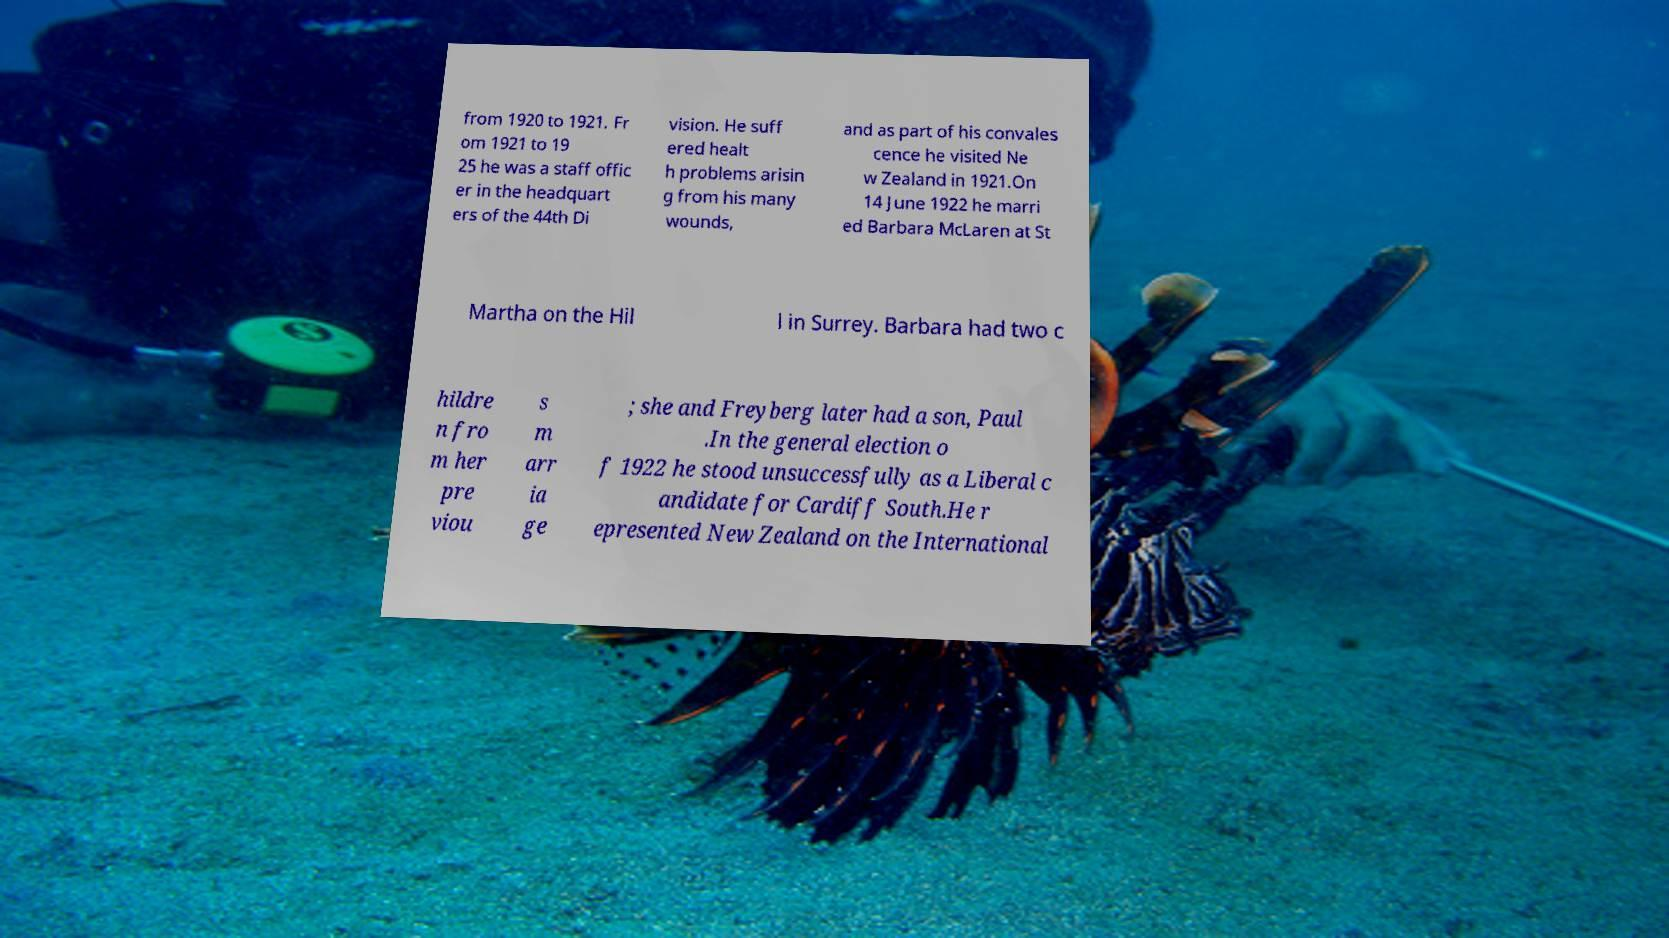Please read and relay the text visible in this image. What does it say? from 1920 to 1921. Fr om 1921 to 19 25 he was a staff offic er in the headquart ers of the 44th Di vision. He suff ered healt h problems arisin g from his many wounds, and as part of his convales cence he visited Ne w Zealand in 1921.On 14 June 1922 he marri ed Barbara McLaren at St Martha on the Hil l in Surrey. Barbara had two c hildre n fro m her pre viou s m arr ia ge ; she and Freyberg later had a son, Paul .In the general election o f 1922 he stood unsuccessfully as a Liberal c andidate for Cardiff South.He r epresented New Zealand on the International 